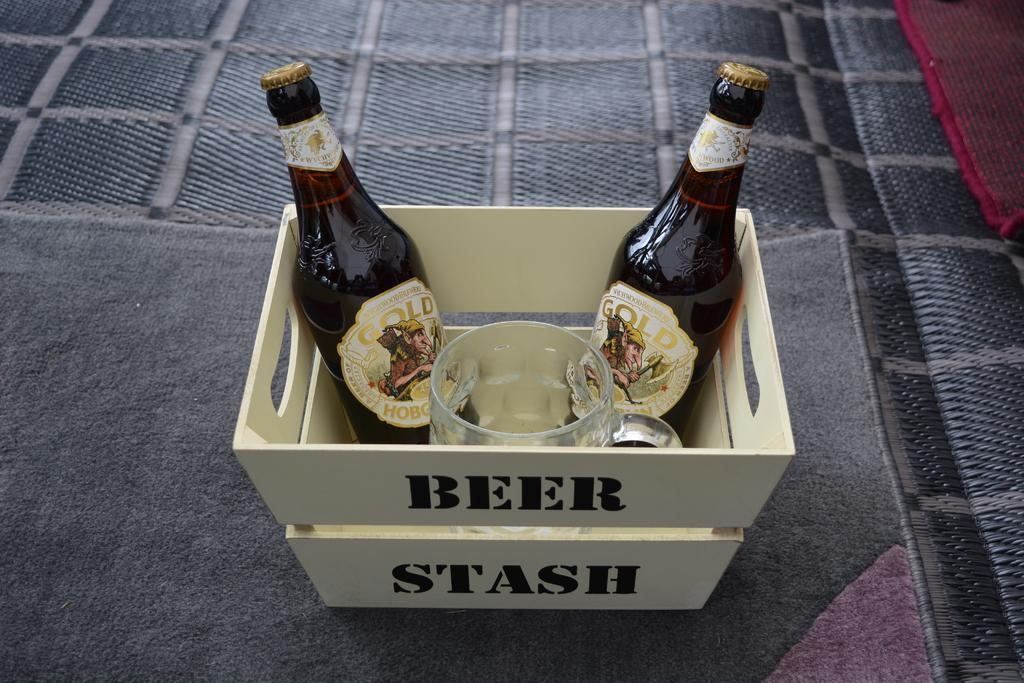<image>
Render a clear and concise summary of the photo. Two bottles of beer in a basket with the words beer stash on it. 